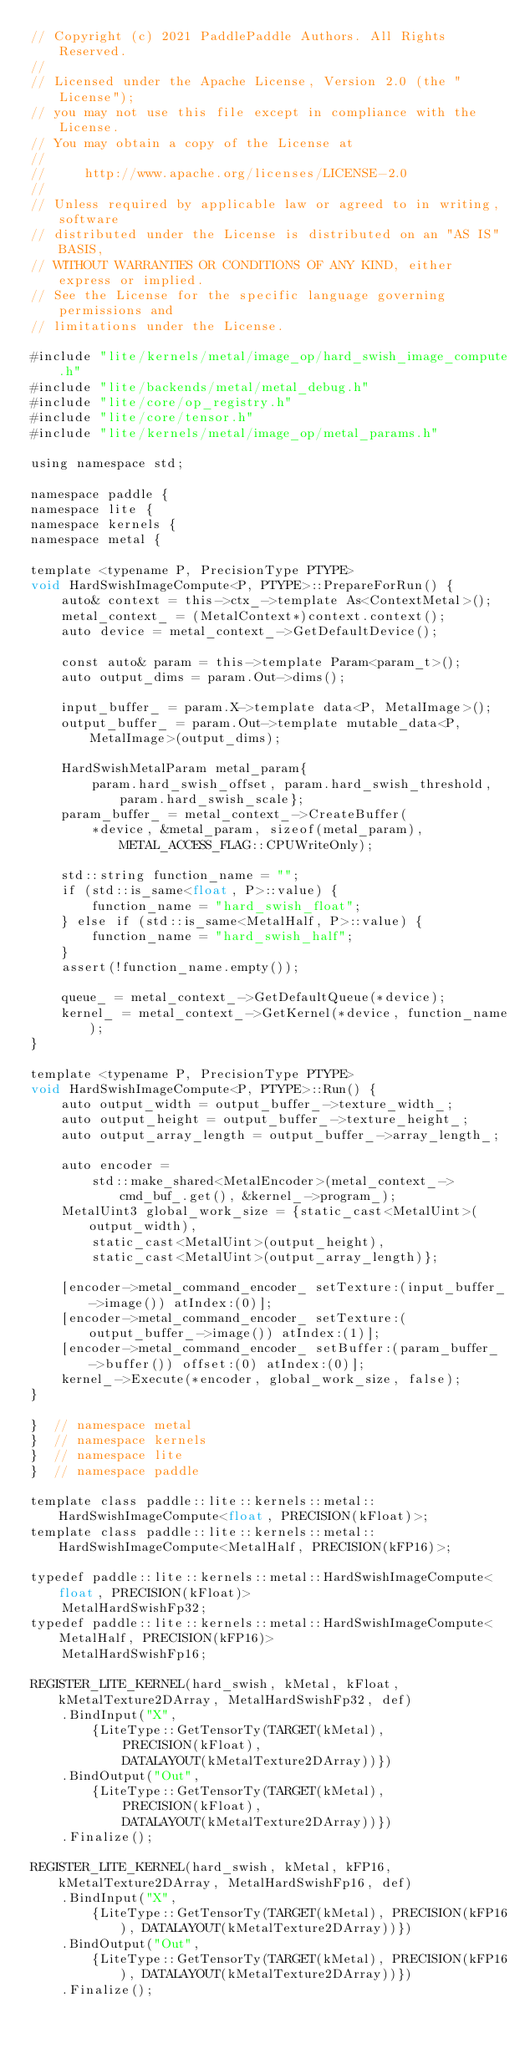Convert code to text. <code><loc_0><loc_0><loc_500><loc_500><_ObjectiveC_>// Copyright (c) 2021 PaddlePaddle Authors. All Rights Reserved.
//
// Licensed under the Apache License, Version 2.0 (the "License");
// you may not use this file except in compliance with the License.
// You may obtain a copy of the License at
//
//     http://www.apache.org/licenses/LICENSE-2.0
//
// Unless required by applicable law or agreed to in writing, software
// distributed under the License is distributed on an "AS IS" BASIS,
// WITHOUT WARRANTIES OR CONDITIONS OF ANY KIND, either express or implied.
// See the License for the specific language governing permissions and
// limitations under the License.

#include "lite/kernels/metal/image_op/hard_swish_image_compute.h"
#include "lite/backends/metal/metal_debug.h"
#include "lite/core/op_registry.h"
#include "lite/core/tensor.h"
#include "lite/kernels/metal/image_op/metal_params.h"

using namespace std;

namespace paddle {
namespace lite {
namespace kernels {
namespace metal {

template <typename P, PrecisionType PTYPE>
void HardSwishImageCompute<P, PTYPE>::PrepareForRun() {
    auto& context = this->ctx_->template As<ContextMetal>();
    metal_context_ = (MetalContext*)context.context();
    auto device = metal_context_->GetDefaultDevice();

    const auto& param = this->template Param<param_t>();
    auto output_dims = param.Out->dims();

    input_buffer_ = param.X->template data<P, MetalImage>();
    output_buffer_ = param.Out->template mutable_data<P, MetalImage>(output_dims);

    HardSwishMetalParam metal_param{
        param.hard_swish_offset, param.hard_swish_threshold, param.hard_swish_scale};
    param_buffer_ = metal_context_->CreateBuffer(
        *device, &metal_param, sizeof(metal_param), METAL_ACCESS_FLAG::CPUWriteOnly);

    std::string function_name = "";
    if (std::is_same<float, P>::value) {
        function_name = "hard_swish_float";
    } else if (std::is_same<MetalHalf, P>::value) {
        function_name = "hard_swish_half";
    }
    assert(!function_name.empty());

    queue_ = metal_context_->GetDefaultQueue(*device);
    kernel_ = metal_context_->GetKernel(*device, function_name);
}

template <typename P, PrecisionType PTYPE>
void HardSwishImageCompute<P, PTYPE>::Run() {
    auto output_width = output_buffer_->texture_width_;
    auto output_height = output_buffer_->texture_height_;
    auto output_array_length = output_buffer_->array_length_;

    auto encoder =
        std::make_shared<MetalEncoder>(metal_context_->cmd_buf_.get(), &kernel_->program_);
    MetalUint3 global_work_size = {static_cast<MetalUint>(output_width),
        static_cast<MetalUint>(output_height),
        static_cast<MetalUint>(output_array_length)};

    [encoder->metal_command_encoder_ setTexture:(input_buffer_->image()) atIndex:(0)];
    [encoder->metal_command_encoder_ setTexture:(output_buffer_->image()) atIndex:(1)];
    [encoder->metal_command_encoder_ setBuffer:(param_buffer_->buffer()) offset:(0) atIndex:(0)];
    kernel_->Execute(*encoder, global_work_size, false);
}

}  // namespace metal
}  // namespace kernels
}  // namespace lite
}  // namespace paddle

template class paddle::lite::kernels::metal::HardSwishImageCompute<float, PRECISION(kFloat)>;
template class paddle::lite::kernels::metal::HardSwishImageCompute<MetalHalf, PRECISION(kFP16)>;

typedef paddle::lite::kernels::metal::HardSwishImageCompute<float, PRECISION(kFloat)>
    MetalHardSwishFp32;
typedef paddle::lite::kernels::metal::HardSwishImageCompute<MetalHalf, PRECISION(kFP16)>
    MetalHardSwishFp16;

REGISTER_LITE_KERNEL(hard_swish, kMetal, kFloat, kMetalTexture2DArray, MetalHardSwishFp32, def)
    .BindInput("X",
        {LiteType::GetTensorTy(TARGET(kMetal),
            PRECISION(kFloat),
            DATALAYOUT(kMetalTexture2DArray))})
    .BindOutput("Out",
        {LiteType::GetTensorTy(TARGET(kMetal),
            PRECISION(kFloat),
            DATALAYOUT(kMetalTexture2DArray))})
    .Finalize();

REGISTER_LITE_KERNEL(hard_swish, kMetal, kFP16, kMetalTexture2DArray, MetalHardSwishFp16, def)
    .BindInput("X",
        {LiteType::GetTensorTy(TARGET(kMetal), PRECISION(kFP16), DATALAYOUT(kMetalTexture2DArray))})
    .BindOutput("Out",
        {LiteType::GetTensorTy(TARGET(kMetal), PRECISION(kFP16), DATALAYOUT(kMetalTexture2DArray))})
    .Finalize();
</code> 